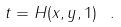Convert formula to latex. <formula><loc_0><loc_0><loc_500><loc_500>t = H ( x , y , 1 ) \ .</formula> 